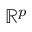<formula> <loc_0><loc_0><loc_500><loc_500>\mathbb { R } ^ { p }</formula> 